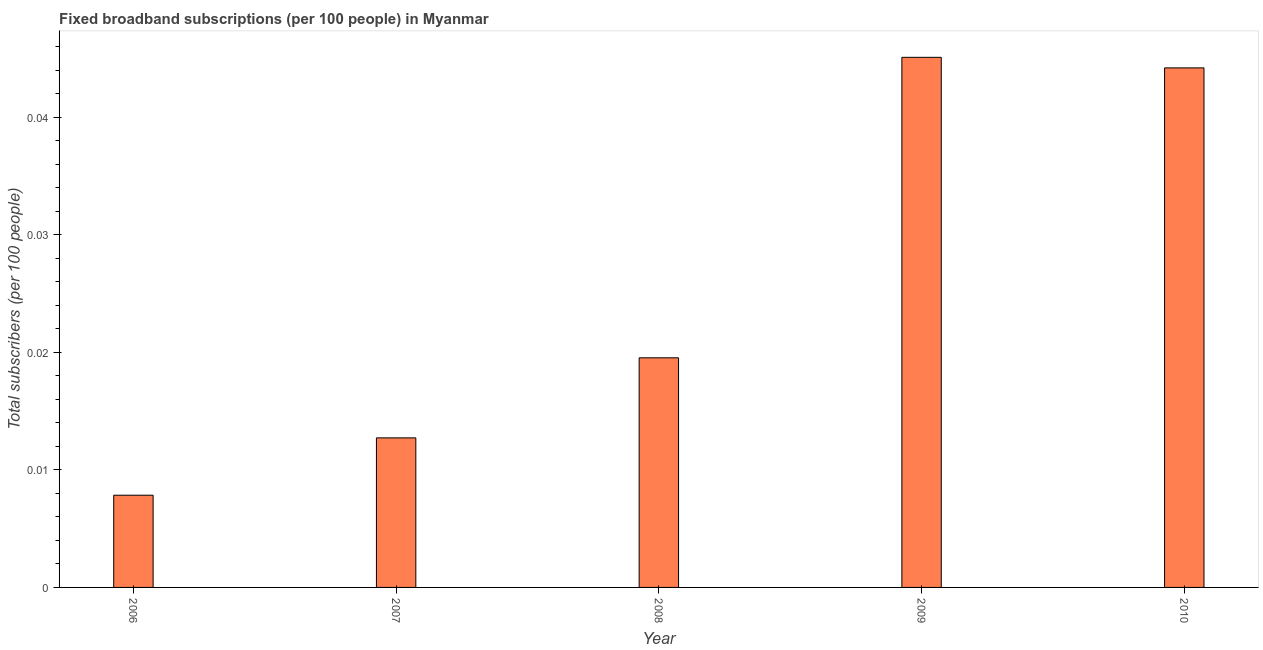Does the graph contain grids?
Offer a terse response. No. What is the title of the graph?
Ensure brevity in your answer.  Fixed broadband subscriptions (per 100 people) in Myanmar. What is the label or title of the Y-axis?
Make the answer very short. Total subscribers (per 100 people). What is the total number of fixed broadband subscriptions in 2009?
Your answer should be very brief. 0.05. Across all years, what is the maximum total number of fixed broadband subscriptions?
Your response must be concise. 0.05. Across all years, what is the minimum total number of fixed broadband subscriptions?
Your answer should be compact. 0.01. In which year was the total number of fixed broadband subscriptions maximum?
Provide a succinct answer. 2009. What is the sum of the total number of fixed broadband subscriptions?
Offer a very short reply. 0.13. What is the difference between the total number of fixed broadband subscriptions in 2007 and 2009?
Give a very brief answer. -0.03. What is the average total number of fixed broadband subscriptions per year?
Your response must be concise. 0.03. What is the median total number of fixed broadband subscriptions?
Keep it short and to the point. 0.02. Do a majority of the years between 2007 and 2010 (inclusive) have total number of fixed broadband subscriptions greater than 0.038 ?
Your answer should be very brief. No. What is the ratio of the total number of fixed broadband subscriptions in 2007 to that in 2008?
Your answer should be very brief. 0.65. Is the difference between the total number of fixed broadband subscriptions in 2007 and 2008 greater than the difference between any two years?
Your answer should be very brief. No. Is the sum of the total number of fixed broadband subscriptions in 2006 and 2010 greater than the maximum total number of fixed broadband subscriptions across all years?
Your answer should be compact. Yes. In how many years, is the total number of fixed broadband subscriptions greater than the average total number of fixed broadband subscriptions taken over all years?
Ensure brevity in your answer.  2. What is the difference between two consecutive major ticks on the Y-axis?
Your answer should be compact. 0.01. What is the Total subscribers (per 100 people) of 2006?
Provide a short and direct response. 0.01. What is the Total subscribers (per 100 people) in 2007?
Make the answer very short. 0.01. What is the Total subscribers (per 100 people) in 2008?
Give a very brief answer. 0.02. What is the Total subscribers (per 100 people) of 2009?
Offer a terse response. 0.05. What is the Total subscribers (per 100 people) in 2010?
Your response must be concise. 0.04. What is the difference between the Total subscribers (per 100 people) in 2006 and 2007?
Make the answer very short. -0. What is the difference between the Total subscribers (per 100 people) in 2006 and 2008?
Make the answer very short. -0.01. What is the difference between the Total subscribers (per 100 people) in 2006 and 2009?
Ensure brevity in your answer.  -0.04. What is the difference between the Total subscribers (per 100 people) in 2006 and 2010?
Offer a terse response. -0.04. What is the difference between the Total subscribers (per 100 people) in 2007 and 2008?
Offer a terse response. -0.01. What is the difference between the Total subscribers (per 100 people) in 2007 and 2009?
Offer a terse response. -0.03. What is the difference between the Total subscribers (per 100 people) in 2007 and 2010?
Give a very brief answer. -0.03. What is the difference between the Total subscribers (per 100 people) in 2008 and 2009?
Your answer should be very brief. -0.03. What is the difference between the Total subscribers (per 100 people) in 2008 and 2010?
Keep it short and to the point. -0.02. What is the difference between the Total subscribers (per 100 people) in 2009 and 2010?
Provide a short and direct response. 0. What is the ratio of the Total subscribers (per 100 people) in 2006 to that in 2007?
Give a very brief answer. 0.62. What is the ratio of the Total subscribers (per 100 people) in 2006 to that in 2008?
Ensure brevity in your answer.  0.4. What is the ratio of the Total subscribers (per 100 people) in 2006 to that in 2009?
Ensure brevity in your answer.  0.17. What is the ratio of the Total subscribers (per 100 people) in 2006 to that in 2010?
Give a very brief answer. 0.18. What is the ratio of the Total subscribers (per 100 people) in 2007 to that in 2008?
Ensure brevity in your answer.  0.65. What is the ratio of the Total subscribers (per 100 people) in 2007 to that in 2009?
Make the answer very short. 0.28. What is the ratio of the Total subscribers (per 100 people) in 2007 to that in 2010?
Keep it short and to the point. 0.29. What is the ratio of the Total subscribers (per 100 people) in 2008 to that in 2009?
Your answer should be very brief. 0.43. What is the ratio of the Total subscribers (per 100 people) in 2008 to that in 2010?
Provide a short and direct response. 0.44. What is the ratio of the Total subscribers (per 100 people) in 2009 to that in 2010?
Your answer should be compact. 1.02. 